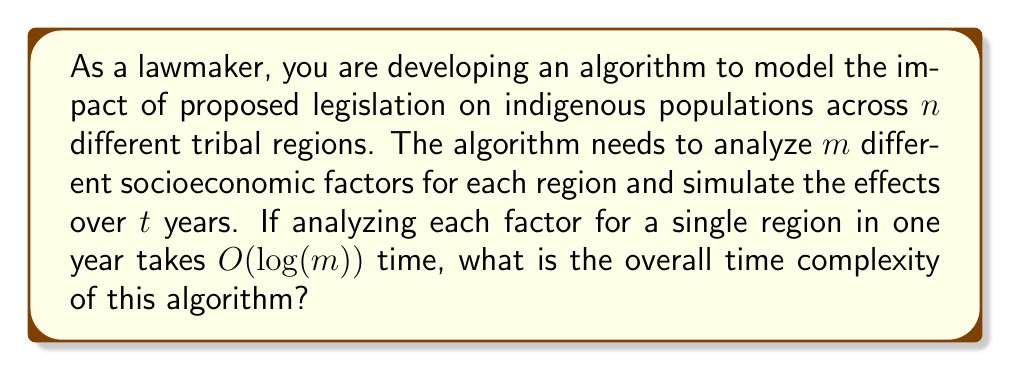Can you answer this question? To determine the overall time complexity of this algorithm, let's break it down step by step:

1. For each region, we need to analyze $m$ factors:
   - Analyzing one factor takes $O(log(m))$ time
   - For $m$ factors, it takes $O(m \cdot log(m))$ time

2. This analysis needs to be done for each of the $n$ regions:
   - For $n$ regions, it becomes $O(n \cdot m \cdot log(m))$

3. The simulation runs for $t$ years, so we multiply the previous complexity by $t$:
   - Final time complexity: $O(t \cdot n \cdot m \cdot log(m))$

We can simplify this notation slightly by considering $t$, $n$, and $m$ as separate input parameters that affect the runtime. The dominant factor in terms of growth is $m \cdot log(m)$, as it grows faster than linear $m$.

It's worth noting that this complexity assumes that the analysis for each year is independent. If there are dependencies between years that require additional computation, the complexity could potentially increase.
Answer: $O(t \cdot n \cdot m \cdot log(m))$ 